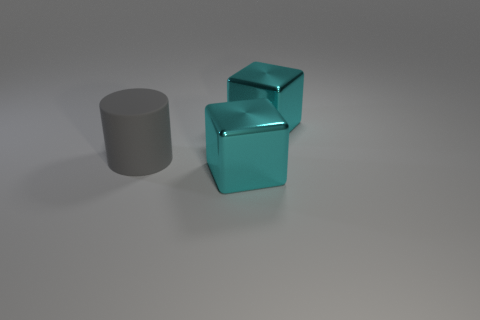What number of cyan metallic blocks have the same size as the gray matte cylinder?
Ensure brevity in your answer.  2. There is a big cyan thing that is behind the gray cylinder; is it the same shape as the large matte thing?
Keep it short and to the point. No. Is the number of big shiny cubes that are in front of the gray thing less than the number of big gray rubber things?
Your answer should be compact. No. Are there any metallic blocks that have the same color as the cylinder?
Your response must be concise. No. There is a big gray thing; is its shape the same as the thing that is behind the gray rubber cylinder?
Your answer should be very brief. No. Is there a thing that has the same material as the cylinder?
Provide a short and direct response. No. There is a cyan object on the left side of the big shiny block behind the big gray thing; are there any cyan shiny things to the left of it?
Your answer should be very brief. No. How many other things are there of the same shape as the rubber object?
Ensure brevity in your answer.  0. What is the color of the metal block on the left side of the metallic block behind the cyan metal thing that is in front of the large rubber thing?
Ensure brevity in your answer.  Cyan. How many cylinders are there?
Keep it short and to the point. 1. 